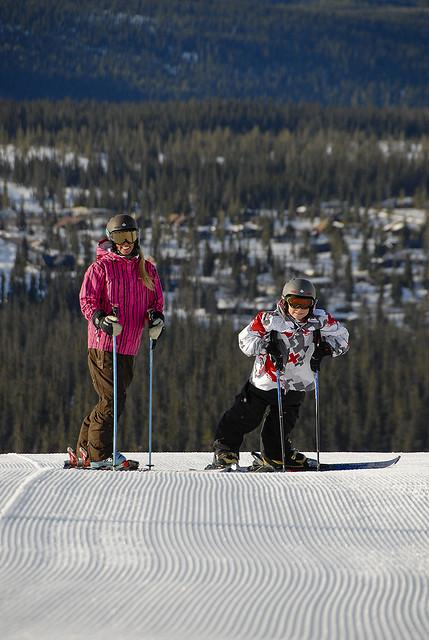What color are the vertical stripes on the left skier's jacket?

Choices:
A) blue
B) black
C) white
D) green black 